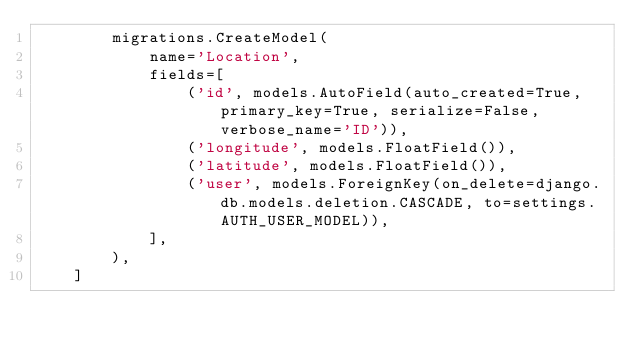Convert code to text. <code><loc_0><loc_0><loc_500><loc_500><_Python_>        migrations.CreateModel(
            name='Location',
            fields=[
                ('id', models.AutoField(auto_created=True, primary_key=True, serialize=False, verbose_name='ID')),
                ('longitude', models.FloatField()),
                ('latitude', models.FloatField()),
                ('user', models.ForeignKey(on_delete=django.db.models.deletion.CASCADE, to=settings.AUTH_USER_MODEL)),
            ],
        ),
    ]
</code> 